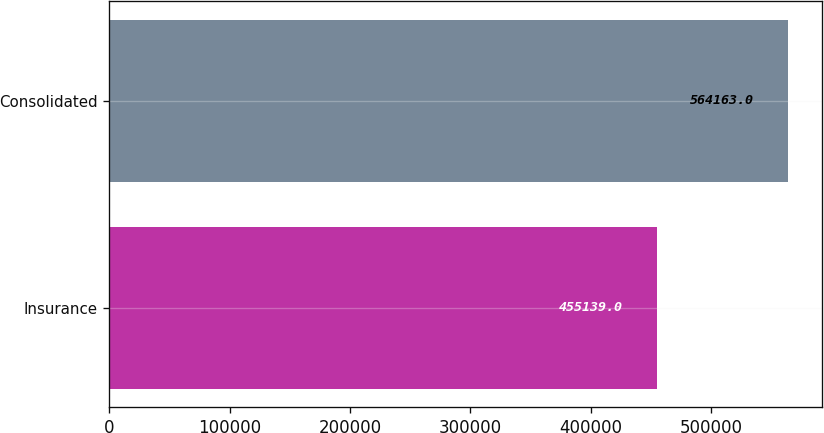<chart> <loc_0><loc_0><loc_500><loc_500><bar_chart><fcel>Insurance<fcel>Consolidated<nl><fcel>455139<fcel>564163<nl></chart> 